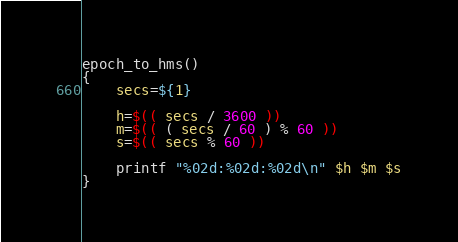Convert code to text. <code><loc_0><loc_0><loc_500><loc_500><_Bash_>epoch_to_hms()
{
	secs=${1}

	h=$(( secs / 3600 ))
	m=$(( ( secs / 60 ) % 60 ))
	s=$(( secs % 60 ))

	printf "%02d:%02d:%02d\n" $h $m $s
}
</code> 